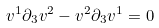Convert formula to latex. <formula><loc_0><loc_0><loc_500><loc_500>v ^ { 1 } \partial _ { 3 } v ^ { 2 } - v ^ { 2 } \partial _ { 3 } v ^ { 1 } = 0</formula> 